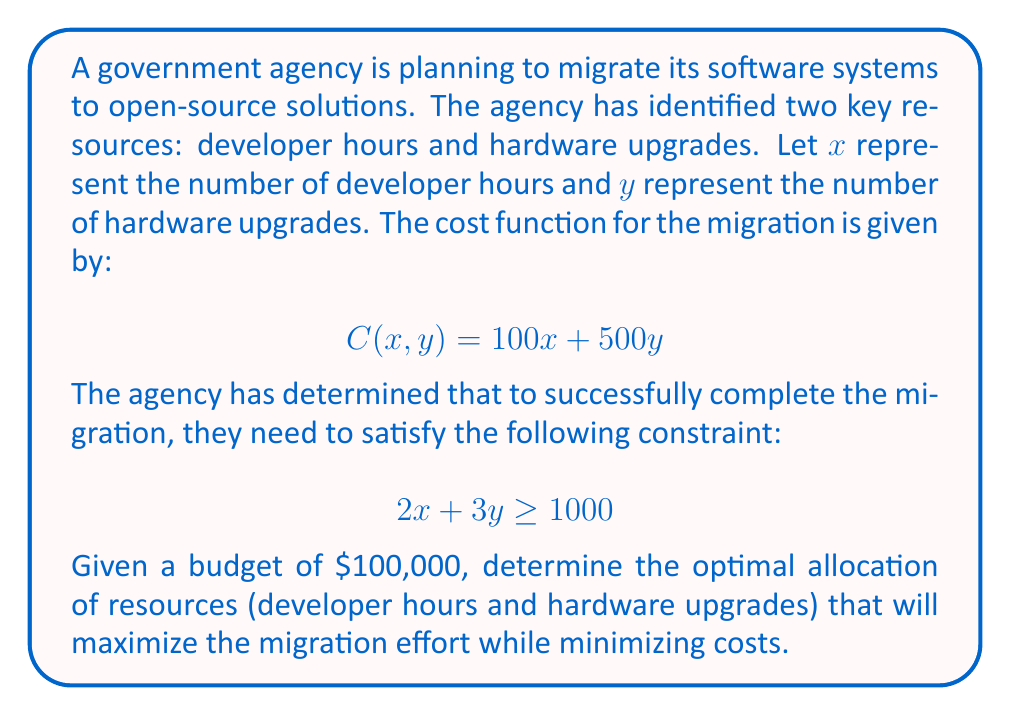Help me with this question. To solve this problem, we'll use linear programming techniques:

1) First, let's identify our objective function and constraints:
   Objective function (to minimize): $C(x,y) = 100x + 500y$
   Constraints: 
   $2x + 3y \geq 1000$ (migration requirement)
   $100x + 500y \leq 100000$ (budget constraint)
   $x \geq 0, y \geq 0$ (non-negativity constraints)

2) We can visualize these constraints on a coordinate plane. The feasible region will be the area that satisfies all constraints.

3) In linear programming, the optimal solution always occurs at a vertex of the feasible region. We need to find these vertices.

4) The vertices occur at the intersections of our constraint lines:
   - Intersection of $2x + 3y = 1000$ and $100x + 500y = 100000$
   - Intersection of $2x + 3y = 1000$ and y-axis (x = 0)
   - Intersection of $100x + 500y = 100000$ and x-axis (y = 0)

5) Let's solve for these intersections:
   a) $2x + 3y = 1000$ and $100x + 500y = 100000$
      Multiply the first equation by 50: $100x + 150y = 50000$
      Subtract from the second equation: $350y = 50000$
      $y \approx 142.86$
      Substituting back: $x \approx 285.71$

   b) When x = 0 in $2x + 3y = 1000$:
      $y \approx 333.33$

   c) When y = 0 in $100x + 500y = 100000$:
      $x = 1000$

6) Evaluate the objective function at these points:
   $(285.71, 142.86)$: $C \approx 100(285.71) + 500(142.86) = 100000$
   $(0, 333.33)$: $C \approx 100(0) + 500(333.33) = 166665$
   $(1000, 0)$: $C = 100(1000) + 500(0) = 100000$

7) The minimum cost occurs at two points: $(285.71, 142.86)$ and $(1000, 0)$. However, $(285.71, 142.86)$ provides a more balanced allocation of resources.
Answer: The optimal allocation of resources is approximately 286 developer hours and 143 hardware upgrades, resulting in a total cost of $100,000. 